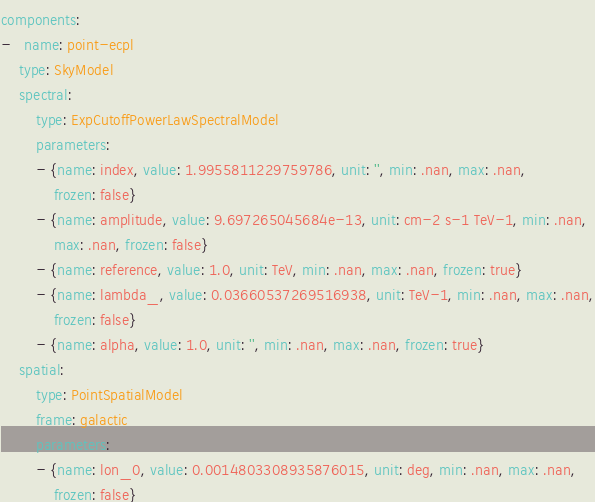Convert code to text. <code><loc_0><loc_0><loc_500><loc_500><_YAML_>components:
-   name: point-ecpl
    type: SkyModel
    spectral:
        type: ExpCutoffPowerLawSpectralModel
        parameters:
        - {name: index, value: 1.9955811229759786, unit: '', min: .nan, max: .nan,
            frozen: false}
        - {name: amplitude, value: 9.697265045684e-13, unit: cm-2 s-1 TeV-1, min: .nan,
            max: .nan, frozen: false}
        - {name: reference, value: 1.0, unit: TeV, min: .nan, max: .nan, frozen: true}
        - {name: lambda_, value: 0.03660537269516938, unit: TeV-1, min: .nan, max: .nan,
            frozen: false}
        - {name: alpha, value: 1.0, unit: '', min: .nan, max: .nan, frozen: true}
    spatial:
        type: PointSpatialModel
        frame: galactic
        parameters:
        - {name: lon_0, value: 0.0014803308935876015, unit: deg, min: .nan, max: .nan,
            frozen: false}</code> 